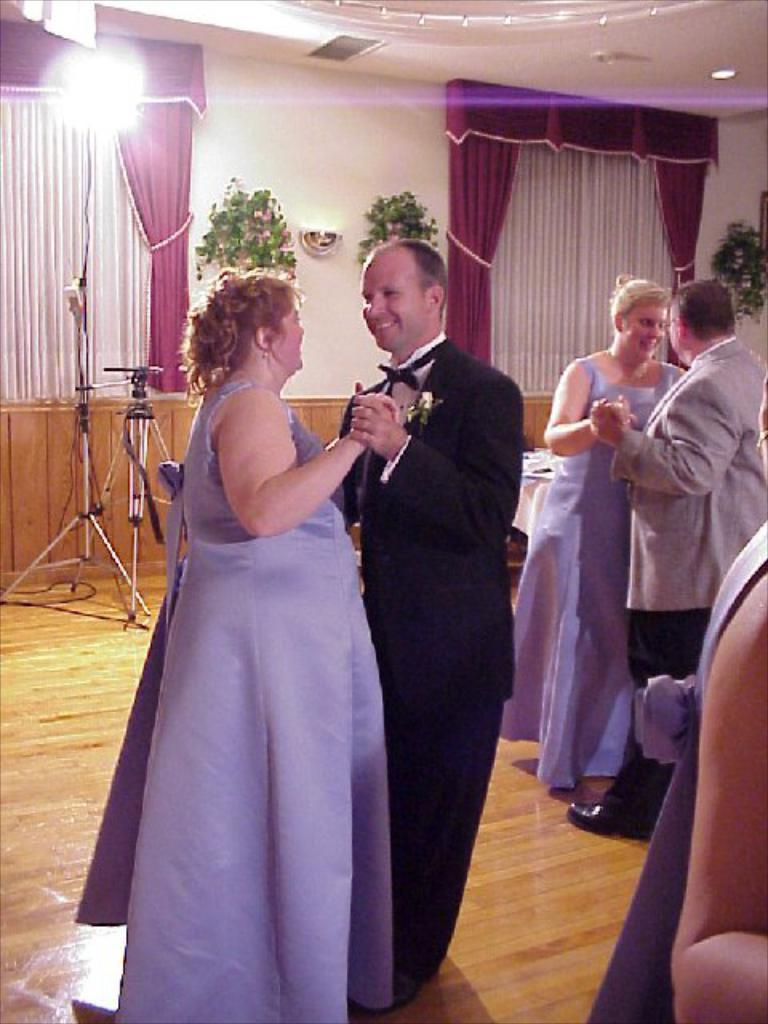What are the people in the image doing? The people in the image are dancing on the floor. What can be seen hanging on the wall? Flower pots are hanging on the wall. What type of structure is present in the image? There are stands in the image. Where is the light source located in the image? A light is attached to the wall. What type of fabric is present in the image? Curtain cloths are present. What part of the room can be seen in the image? The ceiling is visible in the image. What type of rice is being cooked in the image? There is no rice present in the image; it features people dancing and various decorative elements. What is the main character's desire in the image? There is no main character or specific desire depicted in the image; it focuses on people dancing and the surrounding environment. 